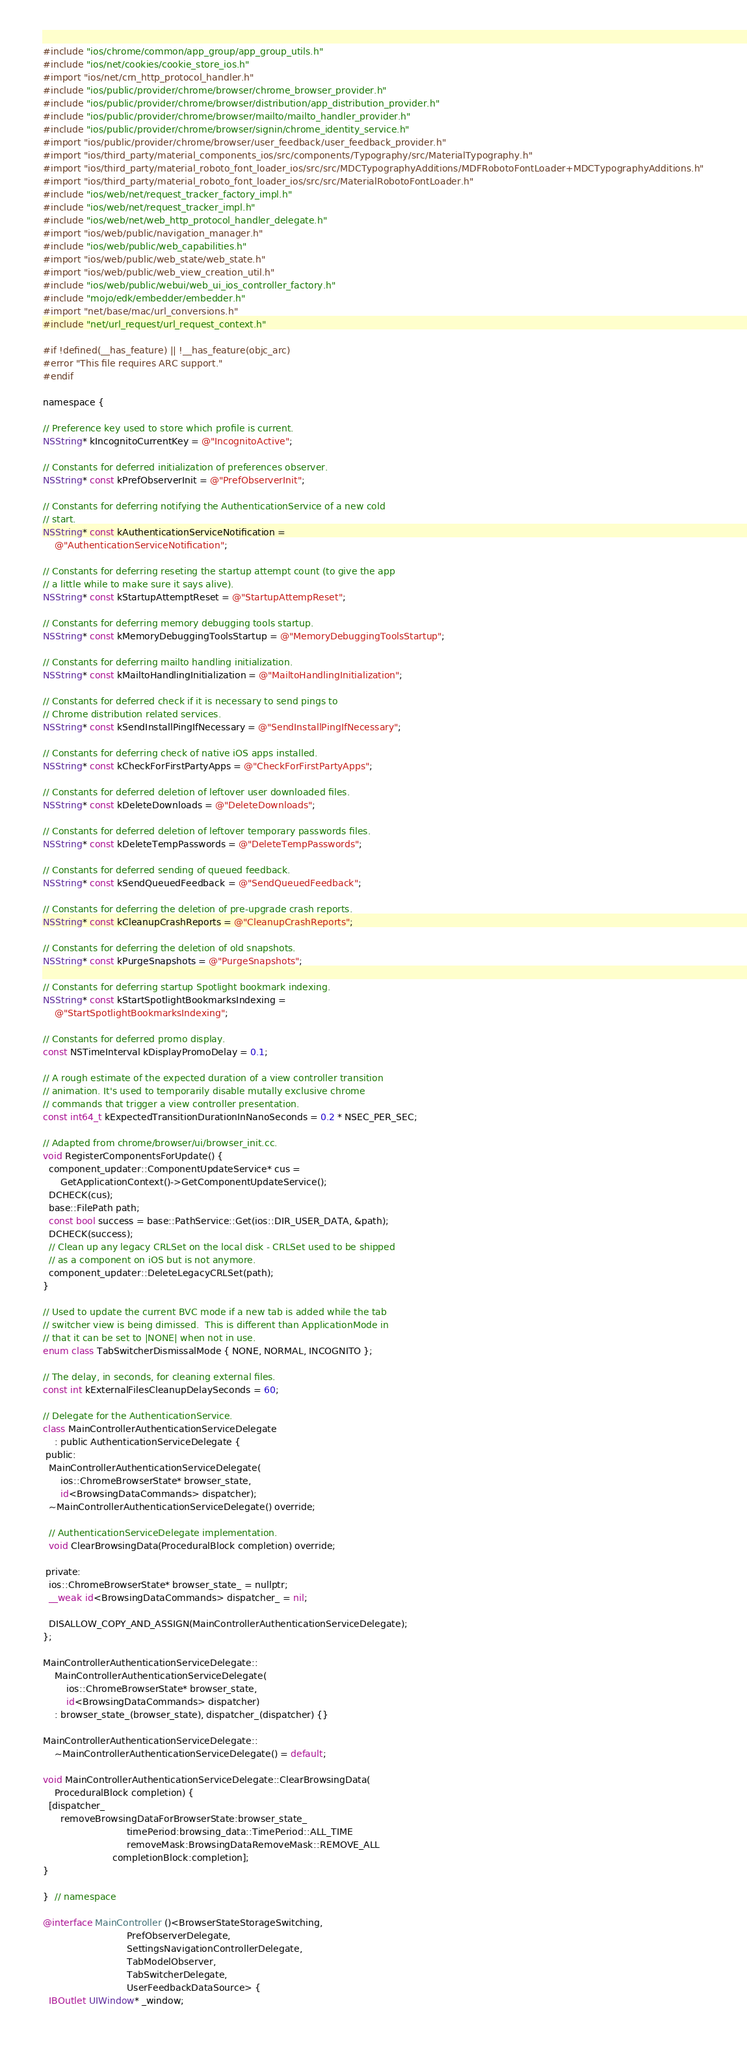<code> <loc_0><loc_0><loc_500><loc_500><_ObjectiveC_>#include "ios/chrome/common/app_group/app_group_utils.h"
#include "ios/net/cookies/cookie_store_ios.h"
#import "ios/net/crn_http_protocol_handler.h"
#include "ios/public/provider/chrome/browser/chrome_browser_provider.h"
#include "ios/public/provider/chrome/browser/distribution/app_distribution_provider.h"
#include "ios/public/provider/chrome/browser/mailto/mailto_handler_provider.h"
#include "ios/public/provider/chrome/browser/signin/chrome_identity_service.h"
#import "ios/public/provider/chrome/browser/user_feedback/user_feedback_provider.h"
#import "ios/third_party/material_components_ios/src/components/Typography/src/MaterialTypography.h"
#import "ios/third_party/material_roboto_font_loader_ios/src/src/MDCTypographyAdditions/MDFRobotoFontLoader+MDCTypographyAdditions.h"
#import "ios/third_party/material_roboto_font_loader_ios/src/src/MaterialRobotoFontLoader.h"
#include "ios/web/net/request_tracker_factory_impl.h"
#include "ios/web/net/request_tracker_impl.h"
#include "ios/web/net/web_http_protocol_handler_delegate.h"
#import "ios/web/public/navigation_manager.h"
#include "ios/web/public/web_capabilities.h"
#import "ios/web/public/web_state/web_state.h"
#import "ios/web/public/web_view_creation_util.h"
#include "ios/web/public/webui/web_ui_ios_controller_factory.h"
#include "mojo/edk/embedder/embedder.h"
#import "net/base/mac/url_conversions.h"
#include "net/url_request/url_request_context.h"

#if !defined(__has_feature) || !__has_feature(objc_arc)
#error "This file requires ARC support."
#endif

namespace {

// Preference key used to store which profile is current.
NSString* kIncognitoCurrentKey = @"IncognitoActive";

// Constants for deferred initialization of preferences observer.
NSString* const kPrefObserverInit = @"PrefObserverInit";

// Constants for deferring notifying the AuthenticationService of a new cold
// start.
NSString* const kAuthenticationServiceNotification =
    @"AuthenticationServiceNotification";

// Constants for deferring reseting the startup attempt count (to give the app
// a little while to make sure it says alive).
NSString* const kStartupAttemptReset = @"StartupAttempReset";

// Constants for deferring memory debugging tools startup.
NSString* const kMemoryDebuggingToolsStartup = @"MemoryDebuggingToolsStartup";

// Constants for deferring mailto handling initialization.
NSString* const kMailtoHandlingInitialization = @"MailtoHandlingInitialization";

// Constants for deferred check if it is necessary to send pings to
// Chrome distribution related services.
NSString* const kSendInstallPingIfNecessary = @"SendInstallPingIfNecessary";

// Constants for deferring check of native iOS apps installed.
NSString* const kCheckForFirstPartyApps = @"CheckForFirstPartyApps";

// Constants for deferred deletion of leftover user downloaded files.
NSString* const kDeleteDownloads = @"DeleteDownloads";

// Constants for deferred deletion of leftover temporary passwords files.
NSString* const kDeleteTempPasswords = @"DeleteTempPasswords";

// Constants for deferred sending of queued feedback.
NSString* const kSendQueuedFeedback = @"SendQueuedFeedback";

// Constants for deferring the deletion of pre-upgrade crash reports.
NSString* const kCleanupCrashReports = @"CleanupCrashReports";

// Constants for deferring the deletion of old snapshots.
NSString* const kPurgeSnapshots = @"PurgeSnapshots";

// Constants for deferring startup Spotlight bookmark indexing.
NSString* const kStartSpotlightBookmarksIndexing =
    @"StartSpotlightBookmarksIndexing";

// Constants for deferred promo display.
const NSTimeInterval kDisplayPromoDelay = 0.1;

// A rough estimate of the expected duration of a view controller transition
// animation. It's used to temporarily disable mutally exclusive chrome
// commands that trigger a view controller presentation.
const int64_t kExpectedTransitionDurationInNanoSeconds = 0.2 * NSEC_PER_SEC;

// Adapted from chrome/browser/ui/browser_init.cc.
void RegisterComponentsForUpdate() {
  component_updater::ComponentUpdateService* cus =
      GetApplicationContext()->GetComponentUpdateService();
  DCHECK(cus);
  base::FilePath path;
  const bool success = base::PathService::Get(ios::DIR_USER_DATA, &path);
  DCHECK(success);
  // Clean up any legacy CRLSet on the local disk - CRLSet used to be shipped
  // as a component on iOS but is not anymore.
  component_updater::DeleteLegacyCRLSet(path);
}

// Used to update the current BVC mode if a new tab is added while the tab
// switcher view is being dimissed.  This is different than ApplicationMode in
// that it can be set to |NONE| when not in use.
enum class TabSwitcherDismissalMode { NONE, NORMAL, INCOGNITO };

// The delay, in seconds, for cleaning external files.
const int kExternalFilesCleanupDelaySeconds = 60;

// Delegate for the AuthenticationService.
class MainControllerAuthenticationServiceDelegate
    : public AuthenticationServiceDelegate {
 public:
  MainControllerAuthenticationServiceDelegate(
      ios::ChromeBrowserState* browser_state,
      id<BrowsingDataCommands> dispatcher);
  ~MainControllerAuthenticationServiceDelegate() override;

  // AuthenticationServiceDelegate implementation.
  void ClearBrowsingData(ProceduralBlock completion) override;

 private:
  ios::ChromeBrowserState* browser_state_ = nullptr;
  __weak id<BrowsingDataCommands> dispatcher_ = nil;

  DISALLOW_COPY_AND_ASSIGN(MainControllerAuthenticationServiceDelegate);
};

MainControllerAuthenticationServiceDelegate::
    MainControllerAuthenticationServiceDelegate(
        ios::ChromeBrowserState* browser_state,
        id<BrowsingDataCommands> dispatcher)
    : browser_state_(browser_state), dispatcher_(dispatcher) {}

MainControllerAuthenticationServiceDelegate::
    ~MainControllerAuthenticationServiceDelegate() = default;

void MainControllerAuthenticationServiceDelegate::ClearBrowsingData(
    ProceduralBlock completion) {
  [dispatcher_
      removeBrowsingDataForBrowserState:browser_state_
                             timePeriod:browsing_data::TimePeriod::ALL_TIME
                             removeMask:BrowsingDataRemoveMask::REMOVE_ALL
                        completionBlock:completion];
}

}  // namespace

@interface MainController ()<BrowserStateStorageSwitching,
                             PrefObserverDelegate,
                             SettingsNavigationControllerDelegate,
                             TabModelObserver,
                             TabSwitcherDelegate,
                             UserFeedbackDataSource> {
  IBOutlet UIWindow* _window;
</code> 